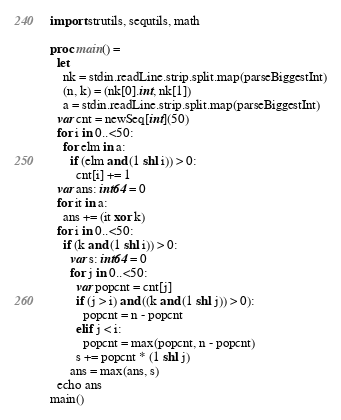<code> <loc_0><loc_0><loc_500><loc_500><_Nim_>import strutils, sequtils, math

proc main() =
  let
    nk = stdin.readLine.strip.split.map(parseBiggestInt)
    (n, k) = (nk[0].int, nk[1])
    a = stdin.readLine.strip.split.map(parseBiggestInt)
  var cnt = newSeq[int](50)
  for i in 0..<50:
    for elm in a:
      if (elm and (1 shl i)) > 0:
        cnt[i] += 1
  var ans: int64 = 0
  for it in a:
    ans += (it xor k)
  for i in 0..<50:
    if (k and (1 shl i)) > 0:
      var s: int64 = 0
      for j in 0..<50:
        var popcnt = cnt[j]
        if (j > i) and ((k and (1 shl j)) > 0):
          popcnt = n - popcnt
        elif j < i:
          popcnt = max(popcnt, n - popcnt)
        s += popcnt * (1 shl j)
      ans = max(ans, s)
  echo ans
main()
</code> 